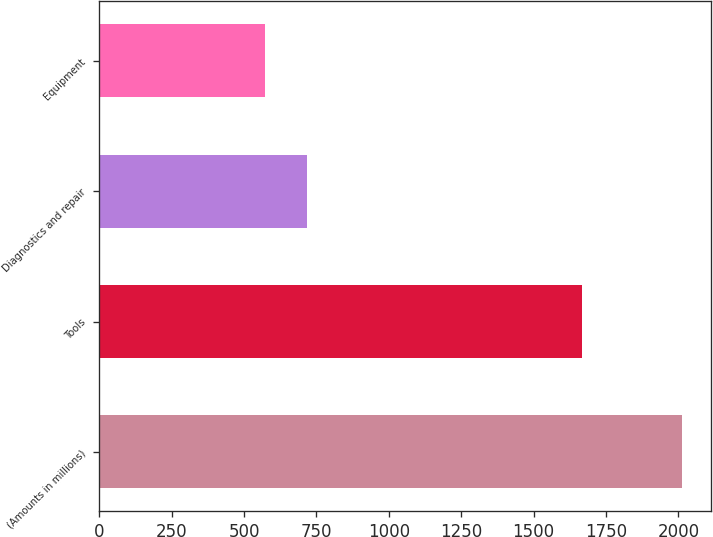Convert chart. <chart><loc_0><loc_0><loc_500><loc_500><bar_chart><fcel>(Amounts in millions)<fcel>Tools<fcel>Diagnostics and repair<fcel>Equipment<nl><fcel>2011<fcel>1667.3<fcel>716.98<fcel>573.2<nl></chart> 